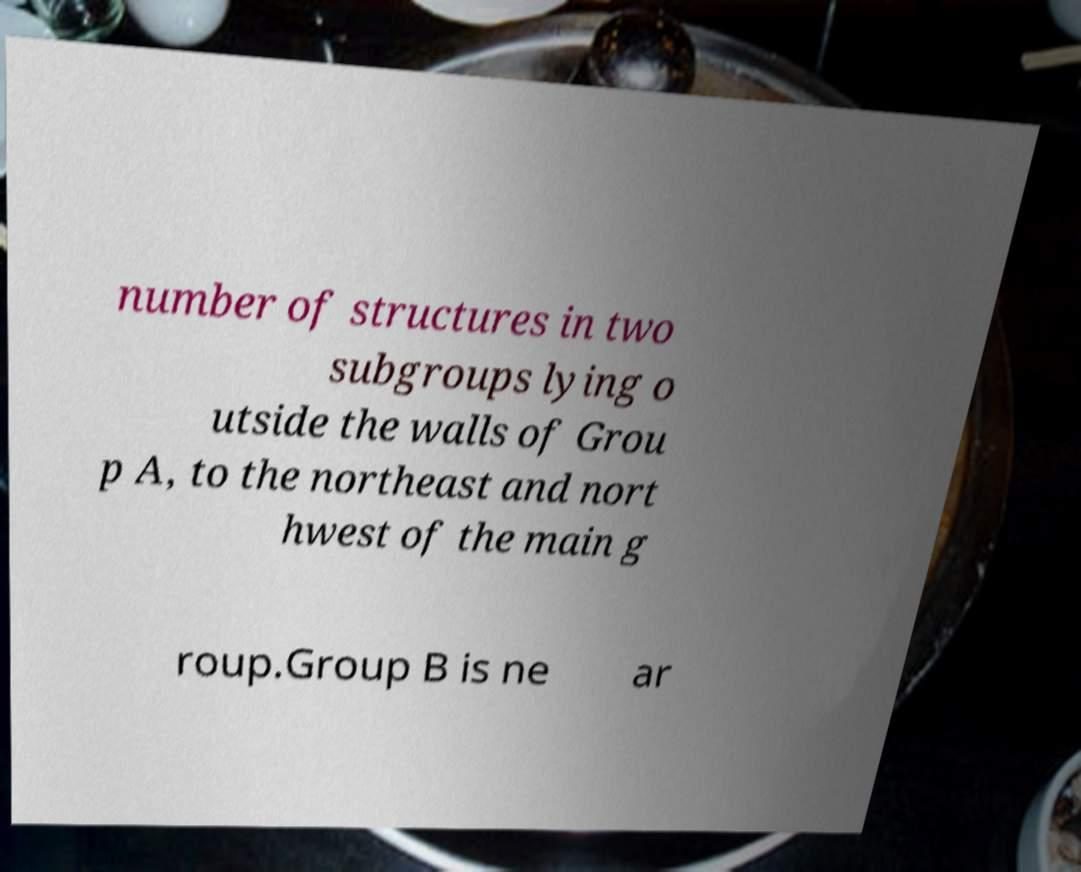What messages or text are displayed in this image? I need them in a readable, typed format. number of structures in two subgroups lying o utside the walls of Grou p A, to the northeast and nort hwest of the main g roup.Group B is ne ar 